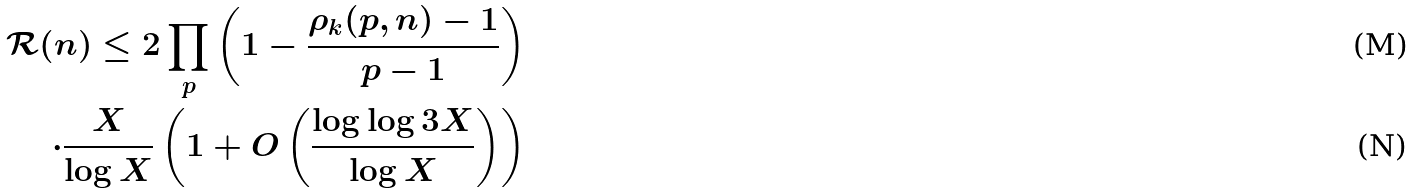<formula> <loc_0><loc_0><loc_500><loc_500>\mathcal { R } ( n ) \leq 2 \prod _ { p } \left ( 1 - \frac { \rho _ { k } ( p , n ) - 1 } { p - 1 } \right ) \\ \cdot \frac { X } { \log X } \left ( 1 + O \left ( \frac { \log \log 3 X } { \log X } \right ) \right )</formula> 